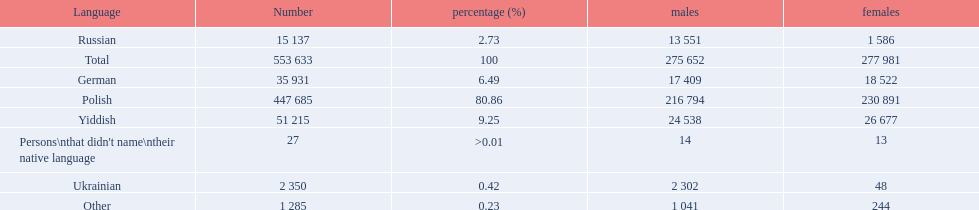What languages are there? Polish, Yiddish, German, Russian, Ukrainian. What numbers speak these languages? 447 685, 51 215, 35 931, 15 137, 2 350. What numbers are not listed as speaking these languages? 1 285, 27. What are the totals of these speakers? 553 633. 